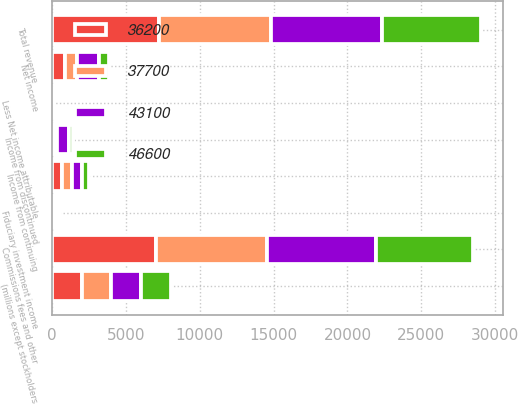<chart> <loc_0><loc_0><loc_500><loc_500><stacked_bar_chart><ecel><fcel>(millions except stockholders<fcel>Commissions fees and other<fcel>Fiduciary investment income<fcel>Total revenue<fcel>Income from continuing<fcel>Income from discontinued<fcel>Net income<fcel>Less Net income attributable<nl><fcel>37700<fcel>2009<fcel>7521<fcel>74<fcel>7595<fcel>681<fcel>111<fcel>792<fcel>45<nl><fcel>43100<fcel>2008<fcel>7357<fcel>171<fcel>7528<fcel>637<fcel>841<fcel>1478<fcel>16<nl><fcel>36200<fcel>2007<fcel>7054<fcel>180<fcel>7234<fcel>675<fcel>202<fcel>877<fcel>13<nl><fcel>46600<fcel>2006<fcel>6546<fcel>142<fcel>6688<fcel>499<fcel>230<fcel>730<fcel>10<nl></chart> 